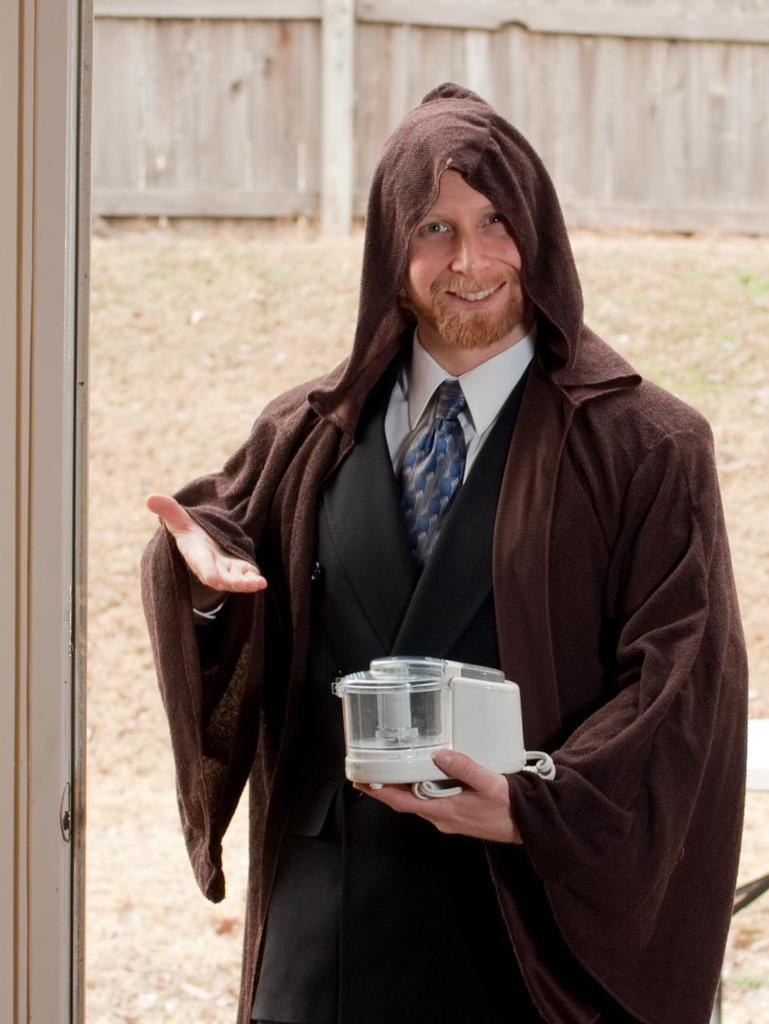Who is present in the image? There is a man in the image. What is the man wearing? The man is wearing a coat. What is the man holding in his hand? The man is holding an object in his hand. What can be seen in the background of the image? There is a wall in the background of the image. What type of riddle is the man solving in the image? There is no riddle present in the image; the man is simply holding an object in his hand. 